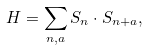Convert formula to latex. <formula><loc_0><loc_0><loc_500><loc_500>H = \sum _ { { n } , { a } } { S } _ { n } \cdot { S } _ { { n } + { a } } ,</formula> 